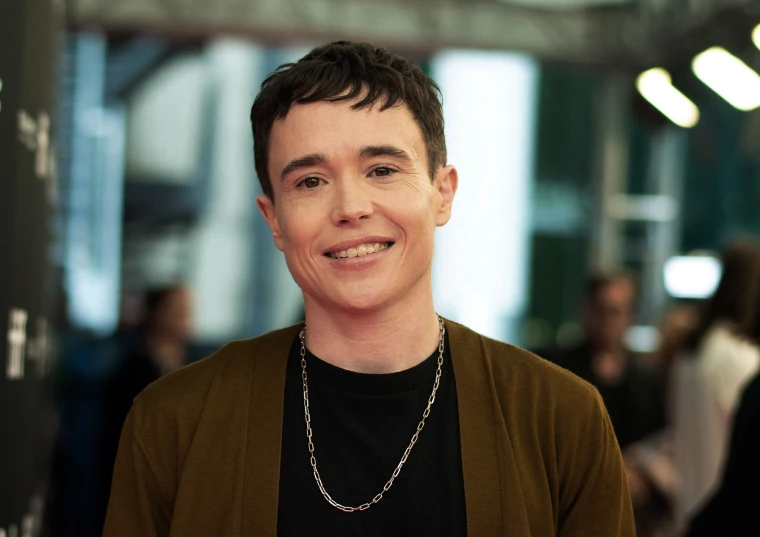What event might this person be attending? This person looks like they are attending a festive event or a film premiere, given the stylish outfit and the joyful expression. The blurred background suggests a bustling environment, perhaps with photographers and fans. 